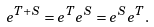<formula> <loc_0><loc_0><loc_500><loc_500>e ^ { T + S } = e ^ { T } e ^ { S } = e ^ { S } e ^ { T } .</formula> 